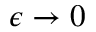Convert formula to latex. <formula><loc_0><loc_0><loc_500><loc_500>\epsilon \to 0</formula> 